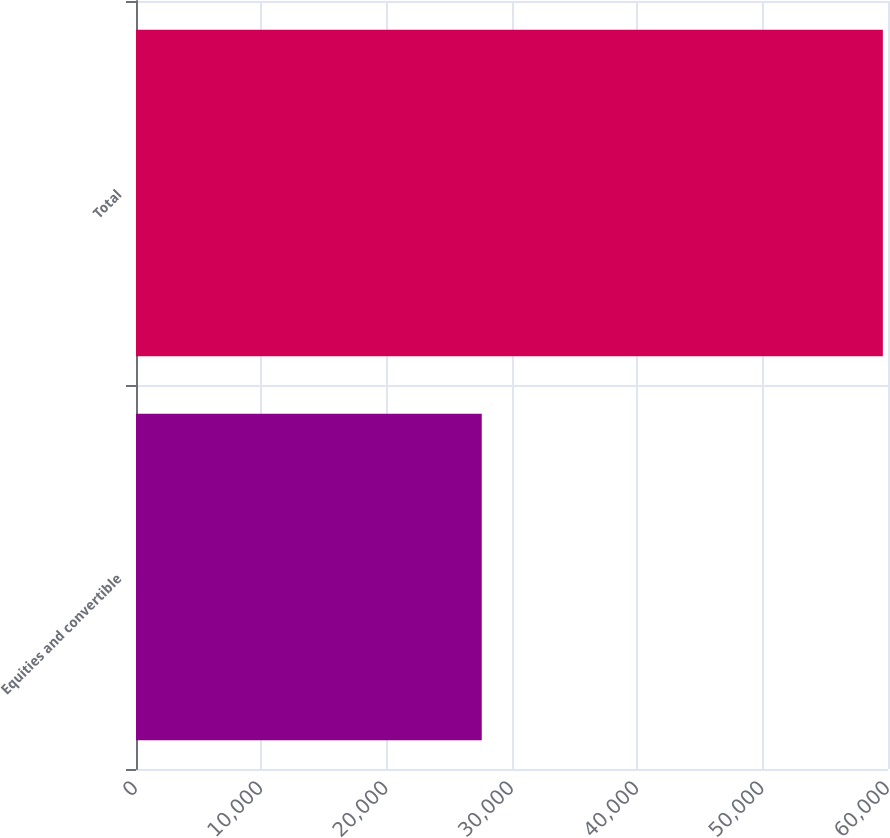Convert chart to OTSL. <chart><loc_0><loc_0><loc_500><loc_500><bar_chart><fcel>Equities and convertible<fcel>Total<nl><fcel>27587<fcel>59589<nl></chart> 